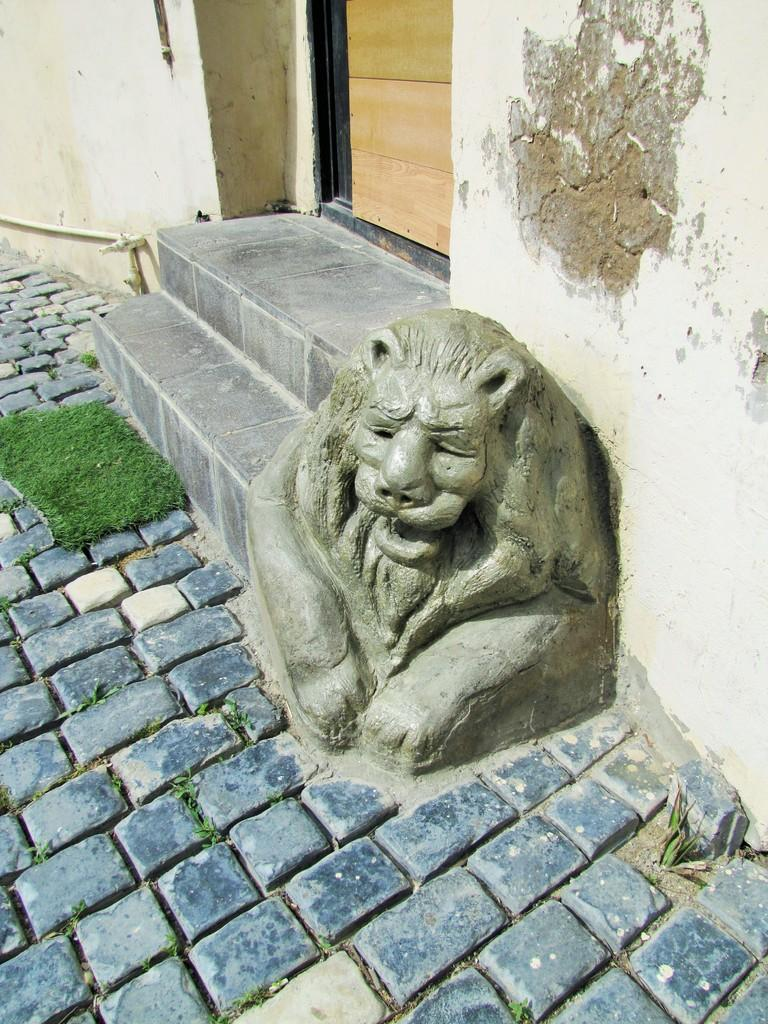What is the main subject of the image? There is a sculpture in the image. What architectural feature is present in the image? There are steps in the image. What is the purpose of the door in the image? The door in the image provides access to a building or room. What is the background of the sculpture made of? The wall in the image serves as the background for the sculpture. What can be seen at the bottom of the image? The floor is visible at the bottom of the image. What type of vegetation is present in the image? There is grass on the right side of the image. What type of question is being asked in the image? There is no question being asked in the image; it is a visual representation of a sculpture and its surroundings. 